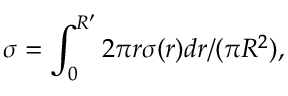Convert formula to latex. <formula><loc_0><loc_0><loc_500><loc_500>\sigma = \int _ { 0 } ^ { R ^ { \prime } } 2 \pi r \sigma ( r ) d r / ( \pi R ^ { 2 } ) ,</formula> 